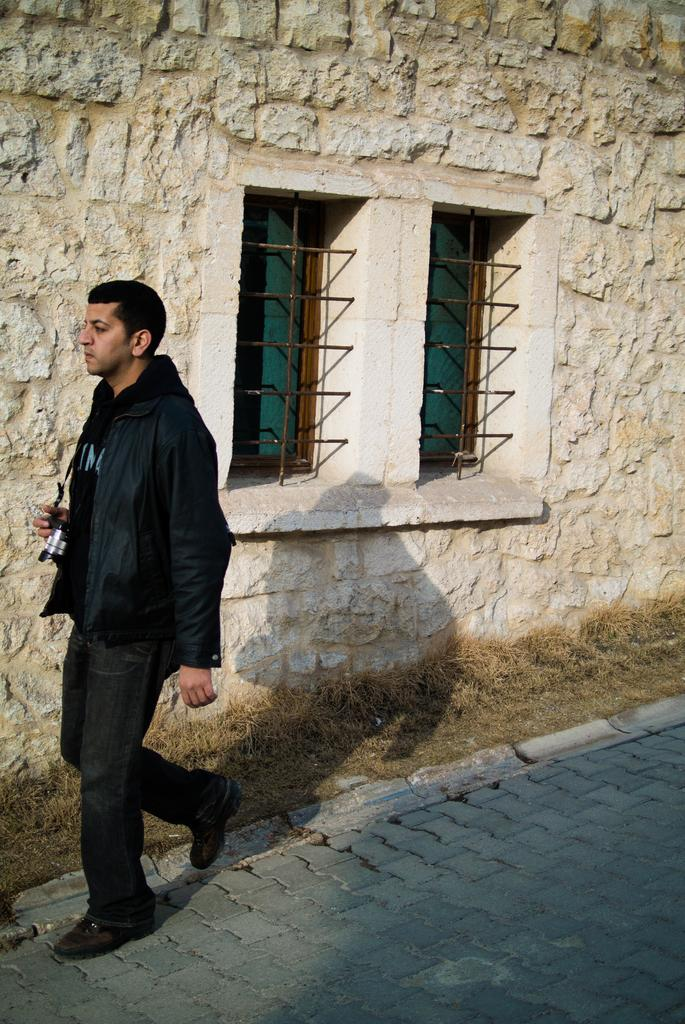Who is present in the image? There is a man in the image. What is the man doing in the image? The man is walking on the left side of the image. What is the man wearing in the image? The man is wearing a black coat, black trousers, and black shoes. What can be seen in the middle of the image? There are windows on a stone wall in the middle of the image. What book is the man reading in the image? There is no book present in the image, and the man is not reading. What taste does the man experience while walking in the image? There is no indication of taste in the image, as it does not involve any food or drink. 